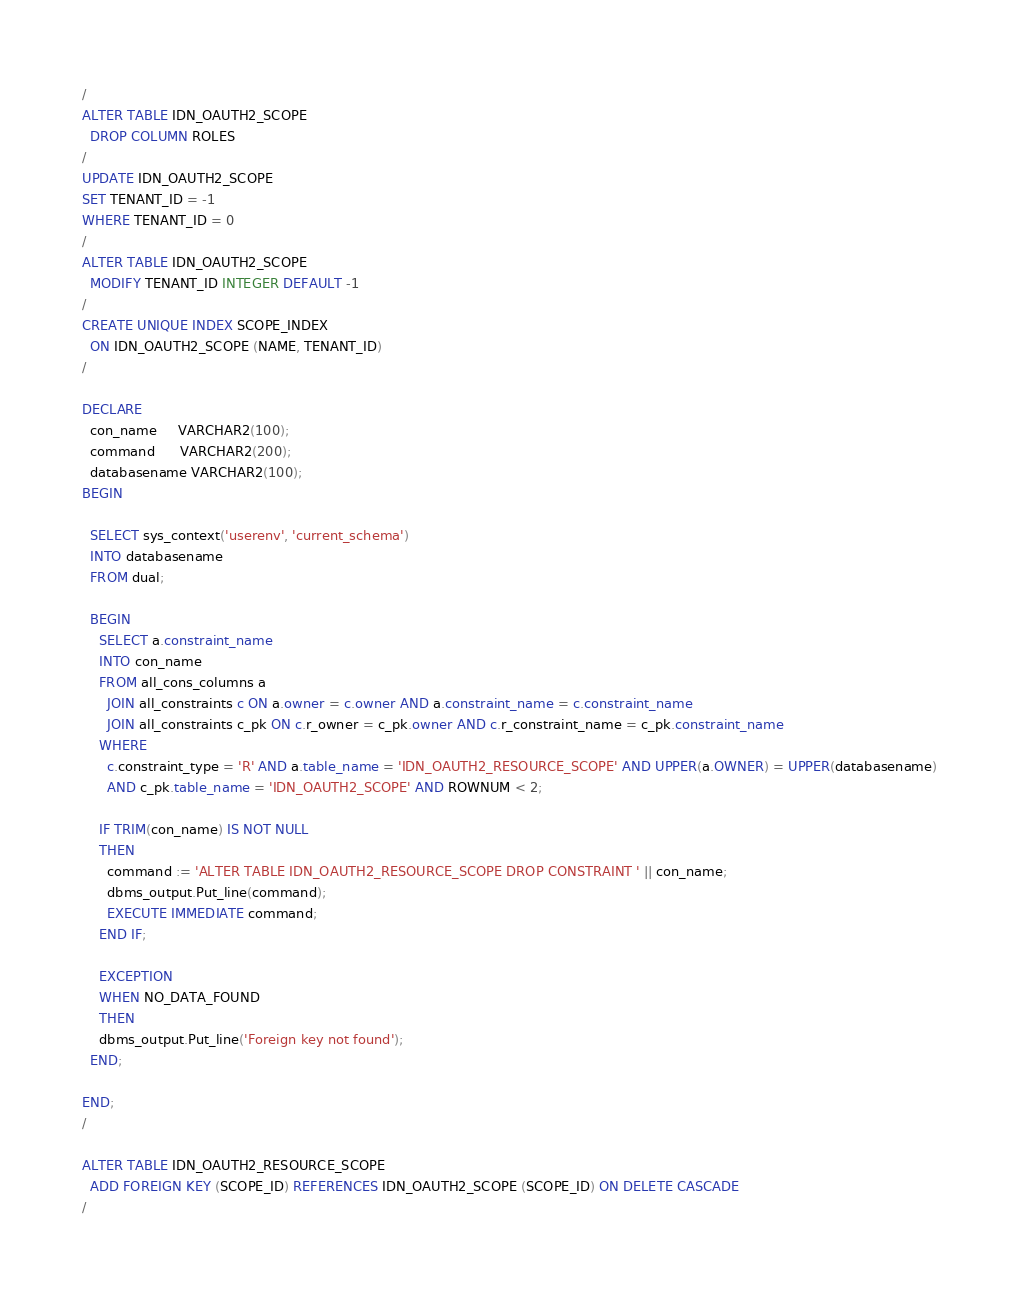Convert code to text. <code><loc_0><loc_0><loc_500><loc_500><_SQL_>/
ALTER TABLE IDN_OAUTH2_SCOPE
  DROP COLUMN ROLES
/
UPDATE IDN_OAUTH2_SCOPE
SET TENANT_ID = -1
WHERE TENANT_ID = 0
/
ALTER TABLE IDN_OAUTH2_SCOPE
  MODIFY TENANT_ID INTEGER DEFAULT -1
/
CREATE UNIQUE INDEX SCOPE_INDEX
  ON IDN_OAUTH2_SCOPE (NAME, TENANT_ID)
/

DECLARE
  con_name     VARCHAR2(100);
  command      VARCHAR2(200);
  databasename VARCHAR2(100);
BEGIN

  SELECT sys_context('userenv', 'current_schema')
  INTO databasename
  FROM dual;

  BEGIN
    SELECT a.constraint_name
    INTO con_name
    FROM all_cons_columns a
      JOIN all_constraints c ON a.owner = c.owner AND a.constraint_name = c.constraint_name
      JOIN all_constraints c_pk ON c.r_owner = c_pk.owner AND c.r_constraint_name = c_pk.constraint_name
    WHERE
      c.constraint_type = 'R' AND a.table_name = 'IDN_OAUTH2_RESOURCE_SCOPE' AND UPPER(a.OWNER) = UPPER(databasename)
      AND c_pk.table_name = 'IDN_OAUTH2_SCOPE' AND ROWNUM < 2;

    IF TRIM(con_name) IS NOT NULL
    THEN
      command := 'ALTER TABLE IDN_OAUTH2_RESOURCE_SCOPE DROP CONSTRAINT ' || con_name;
      dbms_output.Put_line(command);
      EXECUTE IMMEDIATE command;
    END IF;

    EXCEPTION
    WHEN NO_DATA_FOUND
    THEN
    dbms_output.Put_line('Foreign key not found');
  END;

END;
/

ALTER TABLE IDN_OAUTH2_RESOURCE_SCOPE
  ADD FOREIGN KEY (SCOPE_ID) REFERENCES IDN_OAUTH2_SCOPE (SCOPE_ID) ON DELETE CASCADE
/
</code> 